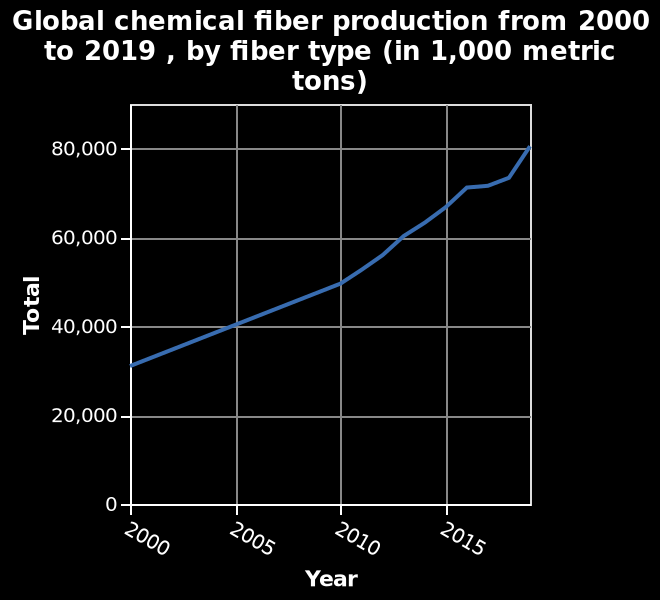<image>
What can be concluded about the production trend from 2005 to 2020? The production trend from 2005 to 2020 is increasing. Offer a thorough analysis of the image. The x axis goes up in intervals of 5 yearsThe graph has an upwards positive trendProduction is 2020 is double that of 2005. 